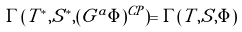Convert formula to latex. <formula><loc_0><loc_0><loc_500><loc_500>\Gamma ( T ^ { * } , S ^ { * } , ( G ^ { a } \Phi ) ^ { C P } ) = \Gamma ( T , S , \Phi )</formula> 